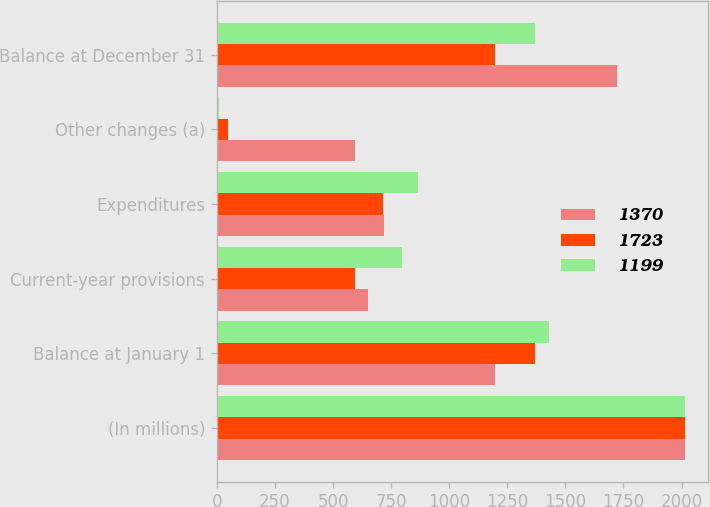Convert chart. <chart><loc_0><loc_0><loc_500><loc_500><stacked_bar_chart><ecel><fcel>(In millions)<fcel>Balance at January 1<fcel>Current-year provisions<fcel>Expenditures<fcel>Other changes (a)<fcel>Balance at December 31<nl><fcel>1370<fcel>2015<fcel>1199<fcel>649<fcel>718<fcel>593<fcel>1723<nl><fcel>1723<fcel>2014<fcel>1370<fcel>593<fcel>714<fcel>50<fcel>1199<nl><fcel>1199<fcel>2013<fcel>1429<fcel>798<fcel>867<fcel>10<fcel>1370<nl></chart> 